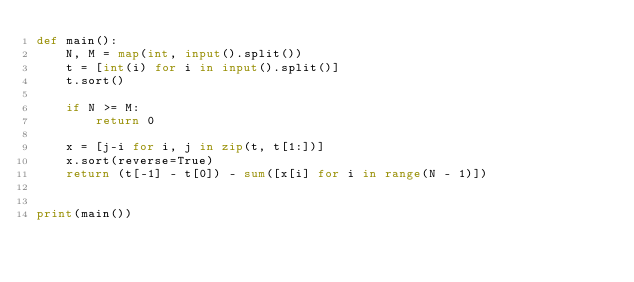Convert code to text. <code><loc_0><loc_0><loc_500><loc_500><_Python_>def main():
    N, M = map(int, input().split())
    t = [int(i) for i in input().split()]
    t.sort()

    if N >= M:
        return 0

    x = [j-i for i, j in zip(t, t[1:])]
    x.sort(reverse=True)
    return (t[-1] - t[0]) - sum([x[i] for i in range(N - 1)])


print(main())
</code> 